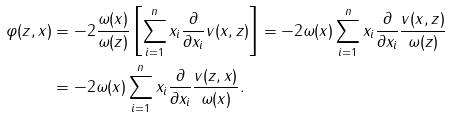<formula> <loc_0><loc_0><loc_500><loc_500>\varphi ( z , x ) & = - 2 \frac { \omega ( x ) } { \omega ( z ) } \left [ \sum _ { i = 1 } ^ { n } x _ { i } \frac { \partial } { \partial x _ { i } } v ( x , z ) \right ] = - 2 \omega ( x ) \sum _ { i = 1 } ^ { n } x _ { i } \frac { \partial } { \partial x _ { i } } \frac { v ( x , z ) } { \omega ( z ) } \\ & = - 2 \omega ( x ) \sum _ { i = 1 } ^ { n } x _ { i } \frac { \partial } { \partial x _ { i } } \frac { v ( z , x ) } { \omega ( x ) } .</formula> 